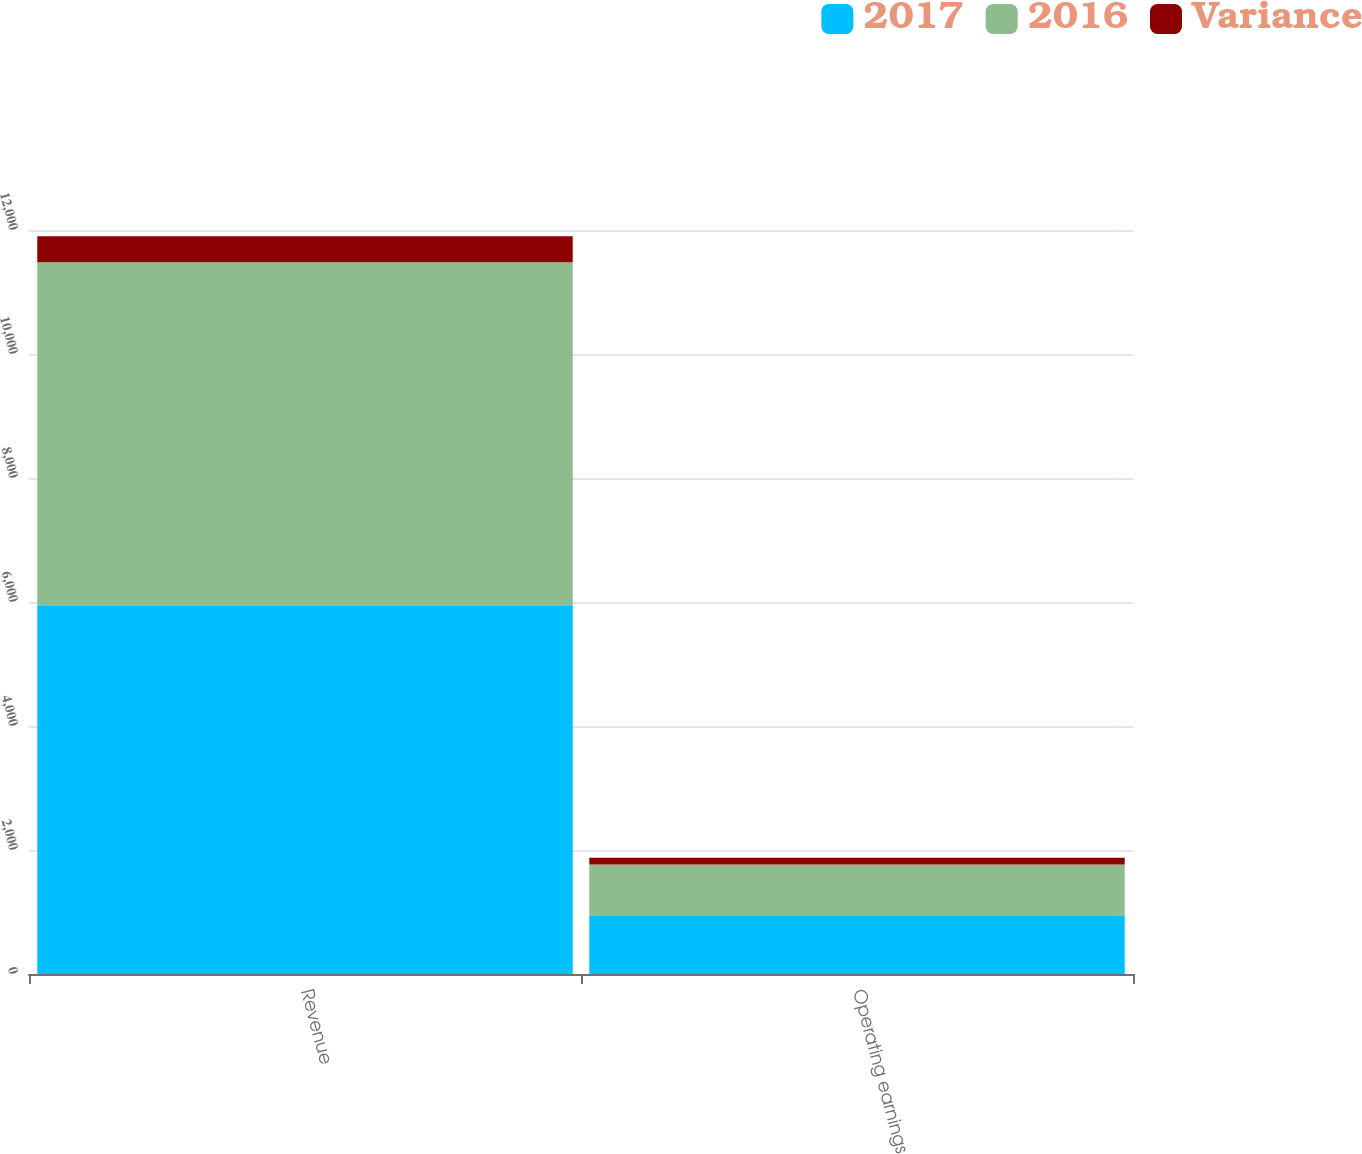Convert chart. <chart><loc_0><loc_0><loc_500><loc_500><stacked_bar_chart><ecel><fcel>Revenue<fcel>Operating earnings<nl><fcel>2017<fcel>5949<fcel>937<nl><fcel>2016<fcel>5530<fcel>831<nl><fcel>Variance<fcel>419<fcel>106<nl></chart> 